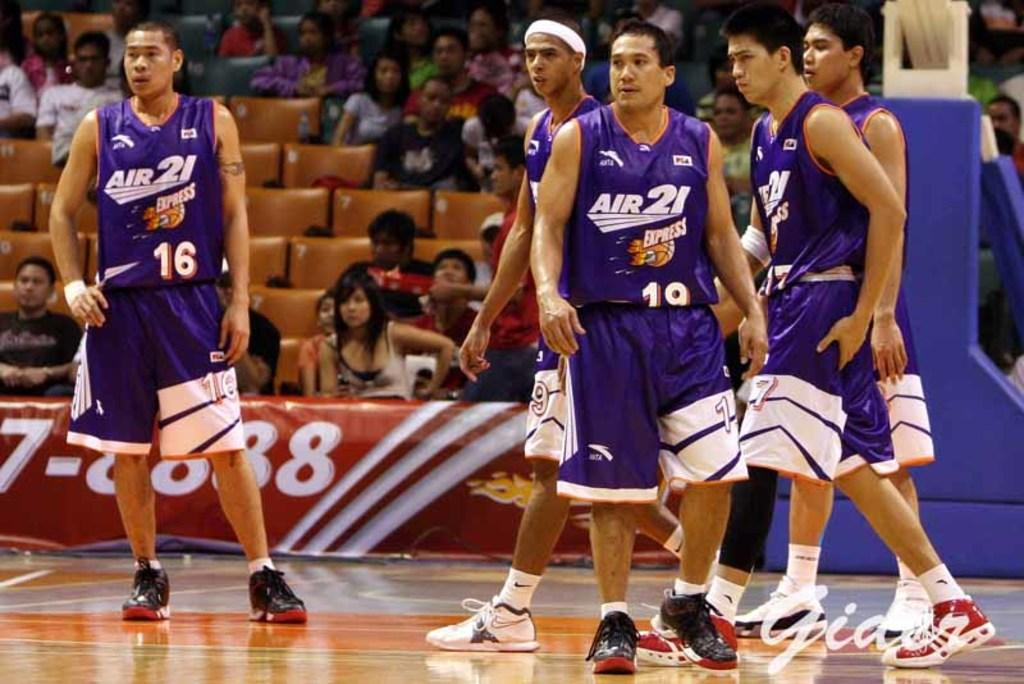Provide a one-sentence caption for the provided image. Basketball players wear bright and colorful Air 21 uniforms. 